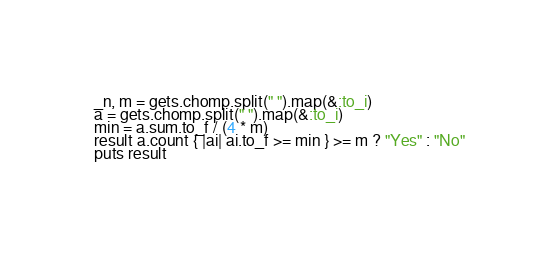<code> <loc_0><loc_0><loc_500><loc_500><_Ruby_>_n, m = gets.chomp.split(" ").map(&:to_i)
a = gets.chomp.split(" ").map(&:to_i)
min = a.sum.to_f / (4 * m)
result a.count { |ai| ai.to_f >= min } >= m ? "Yes" : "No"
puts result
</code> 